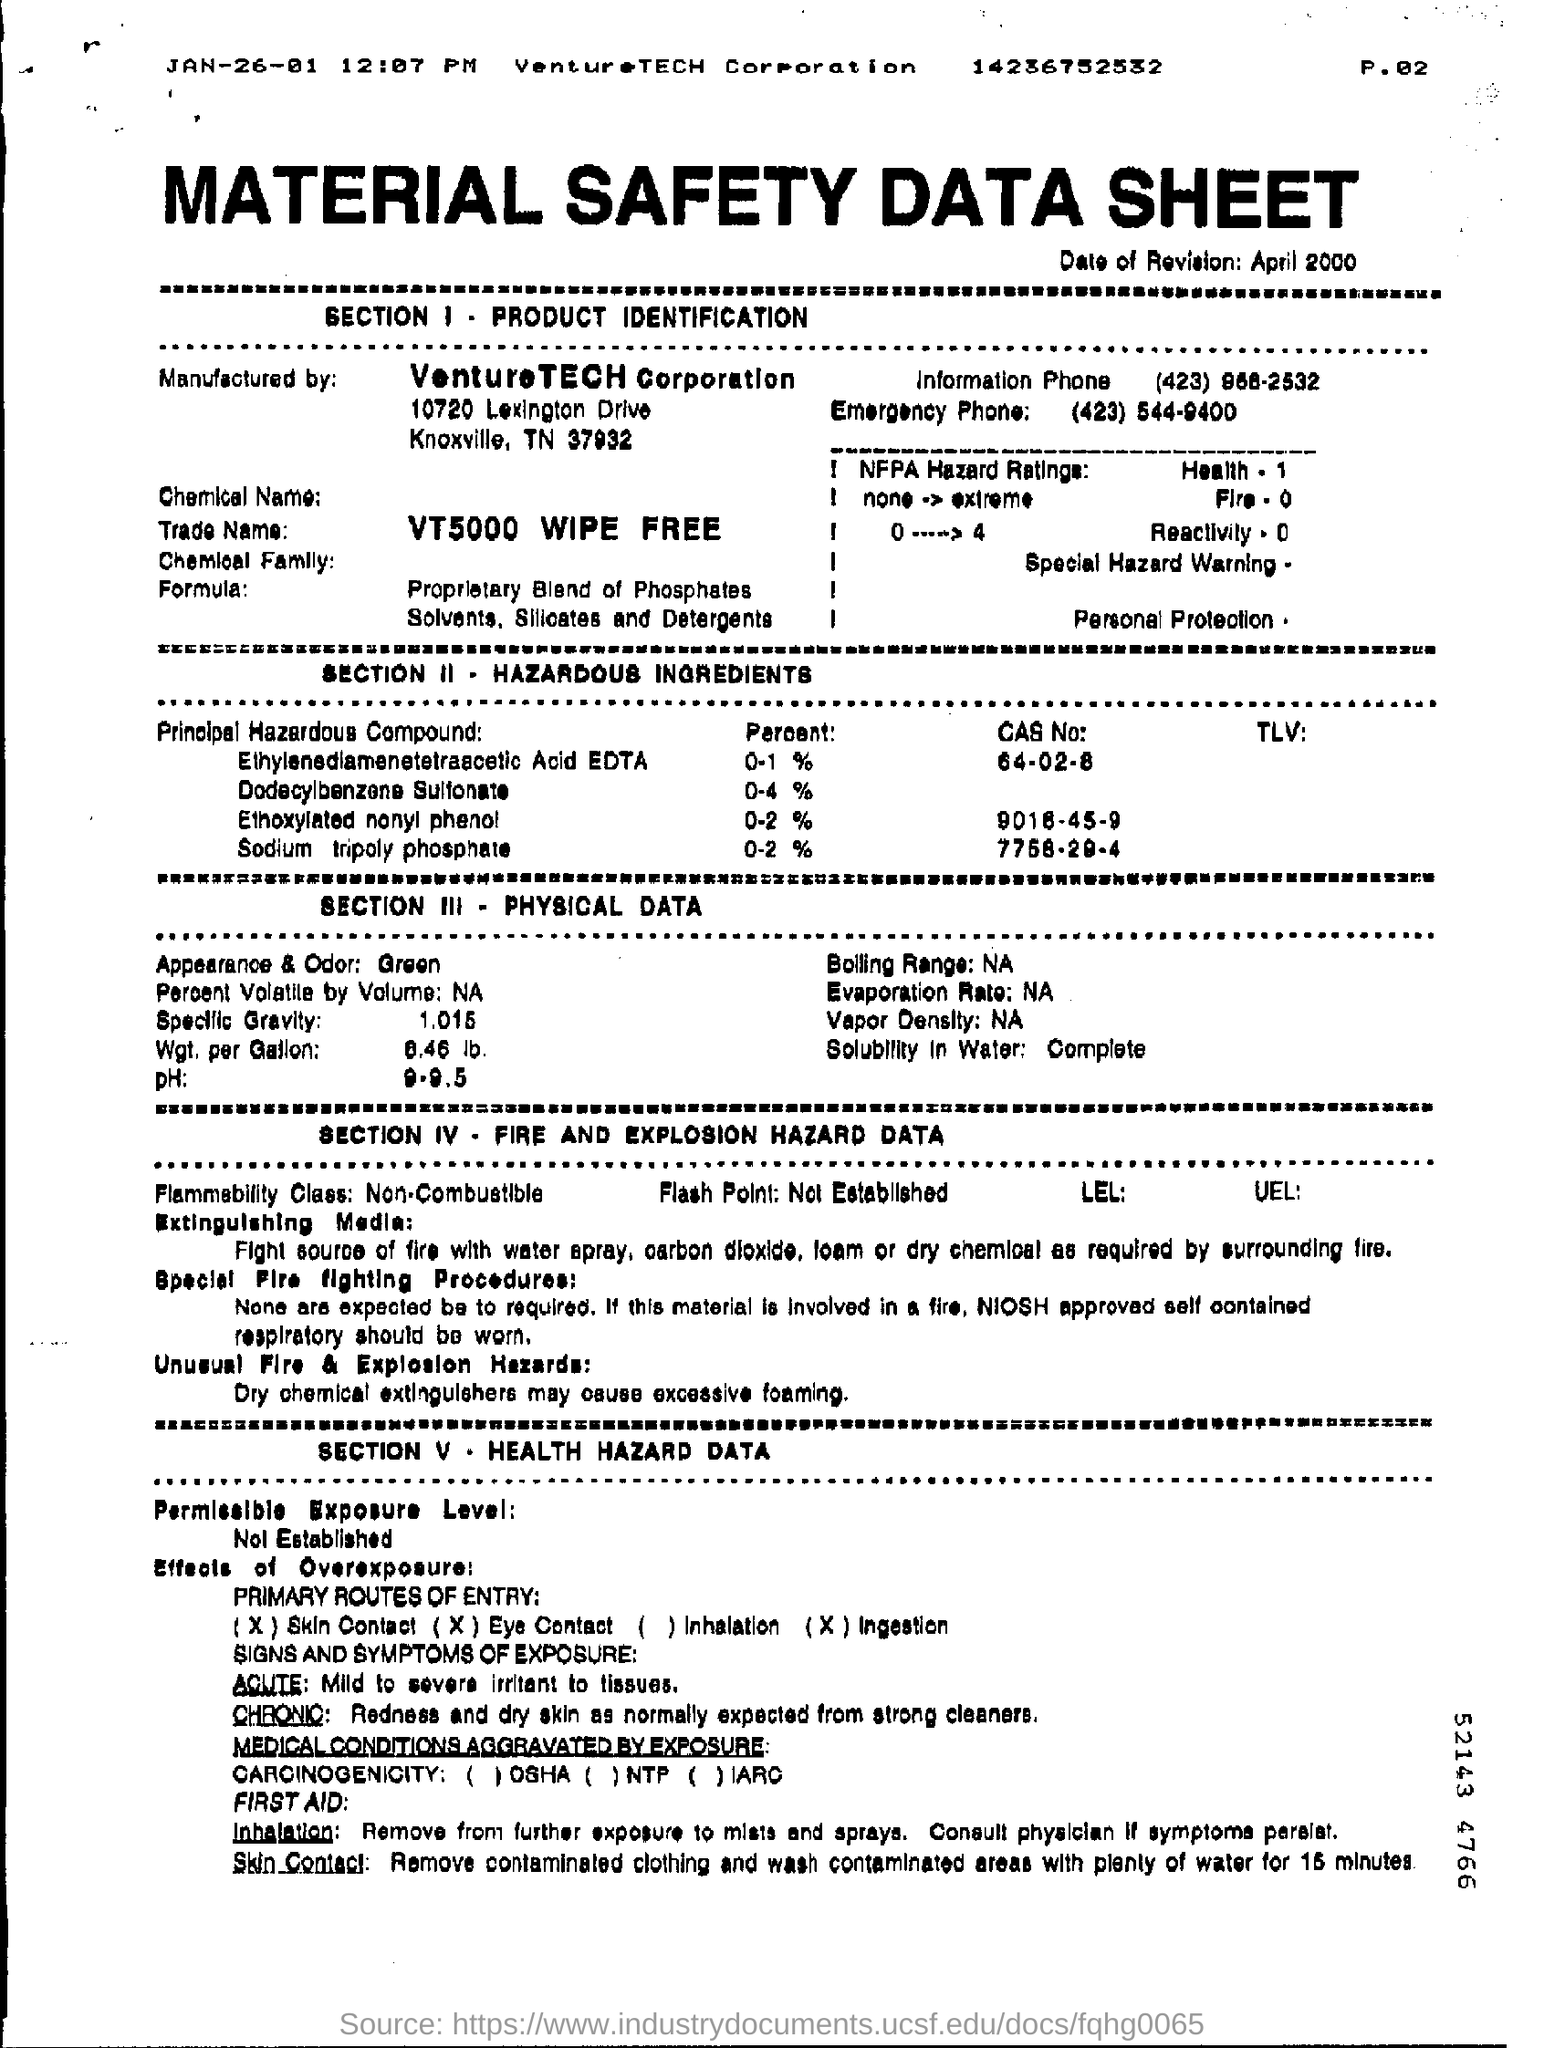Draw attention to some important aspects in this diagram. The specific gravity of the given value is 1.015. SECTION II focuses on hazardous ingredients in cosmetic products. VentureTech Corporation is the manufacturer of the product. The ethoxylated nonyl phenol content is between 0-2%. The date of revision is April 2000. 